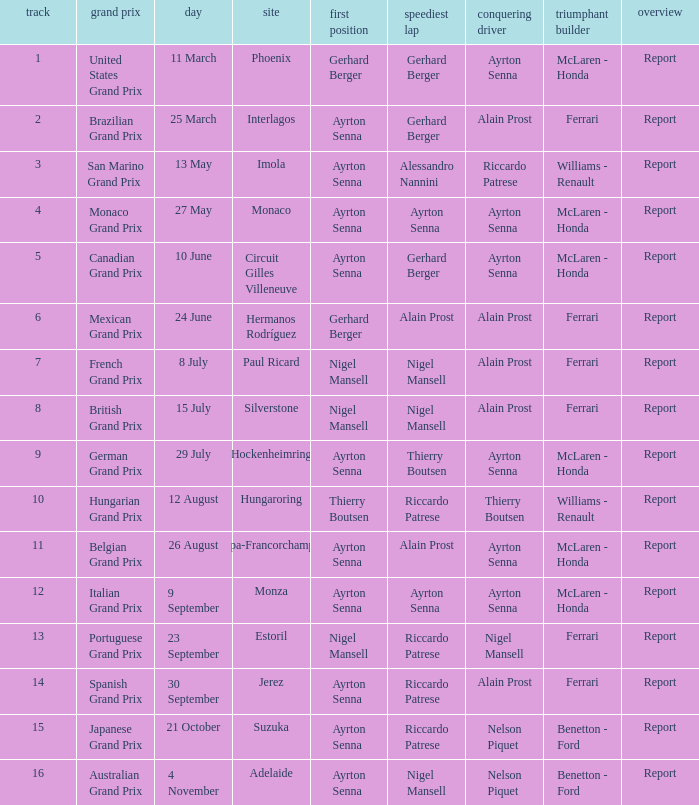What is the Pole Position for the German Grand Prix Ayrton Senna. 